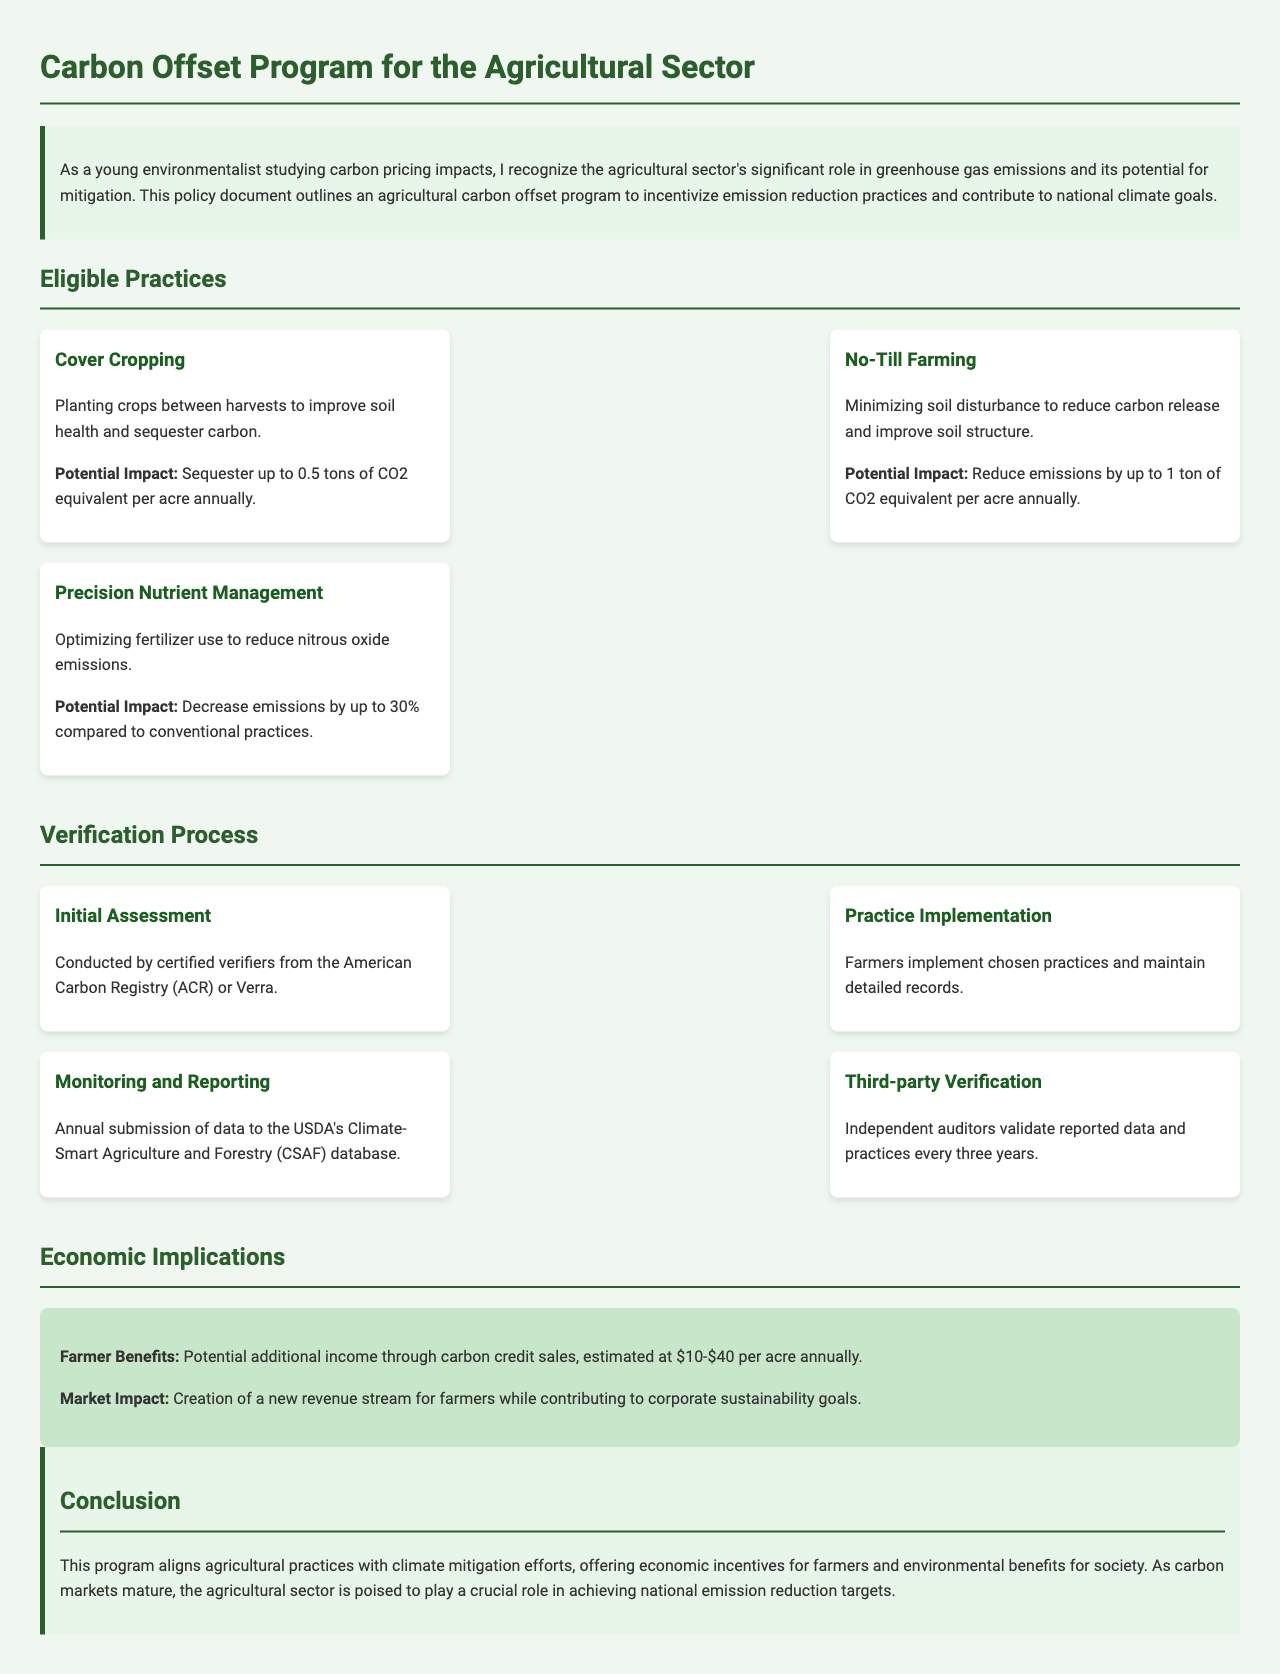what is the first eligible practice mentioned? The first eligible practice listed in the document for carbon offset in agriculture is "Cover Cropping."
Answer: Cover Cropping what is the potential impact of No-Till Farming? The potential impact listed for No-Till Farming indicates that it can reduce emissions significantly.
Answer: Reduce emissions by up to 1 ton of CO2 equivalent per acre annually who conducts the initial assessment? The document specifies that the initial assessment is conducted by certified verifiers.
Answer: Certified verifiers what percentage of reduction in emissions can Precision Nutrient Management achieve? Precision Nutrient Management can decrease emissions compared to conventional practices by a specific percentage given in the document.
Answer: Up to 30% how often is third-party verification conducted? The frequency of third-party verification is mentioned in the document, indicating a specific timeframe.
Answer: Every three years what is the potential additional income per acre for farmers participating in the program? The document provides an estimated range for additional income from carbon credit sales for participating farmers.
Answer: $10-$40 what organization’s database do farmers submit their data to? The database to which farmers submit their data for monitoring and reporting is specified in the document.
Answer: USDA's Climate-Smart Agriculture and Forestry (CSAF) database what is the main economic implication for farmers? The document outlines a primary economic benefit for farmers involved in the carbon offset program.
Answer: Potential additional income through carbon credit sales 